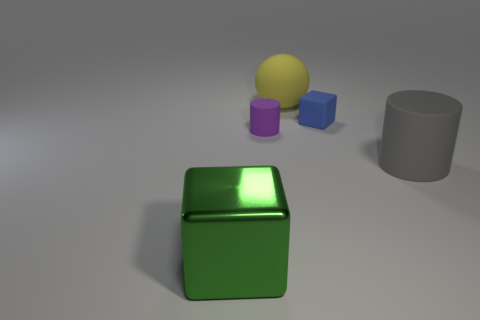How many other objects are there of the same shape as the yellow rubber object?
Give a very brief answer. 0. What size is the object to the right of the tiny block?
Your answer should be compact. Large. There is a block that is behind the large green metal block; is there a green shiny cube that is to the left of it?
Make the answer very short. Yes. What color is the other matte thing that is the same size as the blue matte object?
Give a very brief answer. Purple. Is the number of small blue cubes that are behind the large green shiny thing the same as the number of big gray matte cylinders to the left of the small purple rubber thing?
Give a very brief answer. No. What is the material of the cube in front of the block that is behind the large shiny block?
Give a very brief answer. Metal. How many things are either big cyan rubber things or blue matte blocks?
Ensure brevity in your answer.  1. Is the number of big matte objects less than the number of large red metal balls?
Offer a very short reply. No. There is a gray object that is the same material as the tiny purple thing; what size is it?
Give a very brief answer. Large. The metal thing has what size?
Give a very brief answer. Large. 